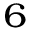<formula> <loc_0><loc_0><loc_500><loc_500>_ { 6 }</formula> 